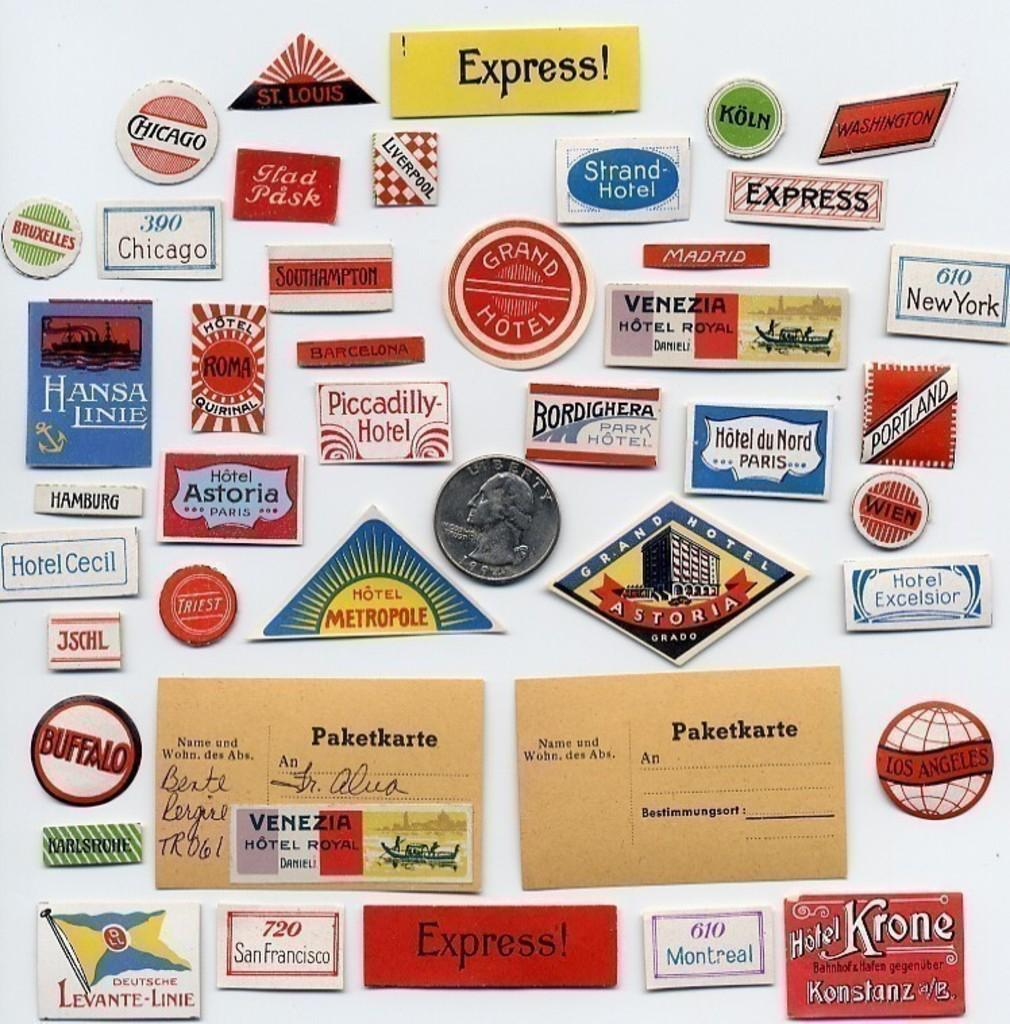Provide a one-sentence caption for the provided image. A collection of gas station and hotel express magnets on a fridge. 